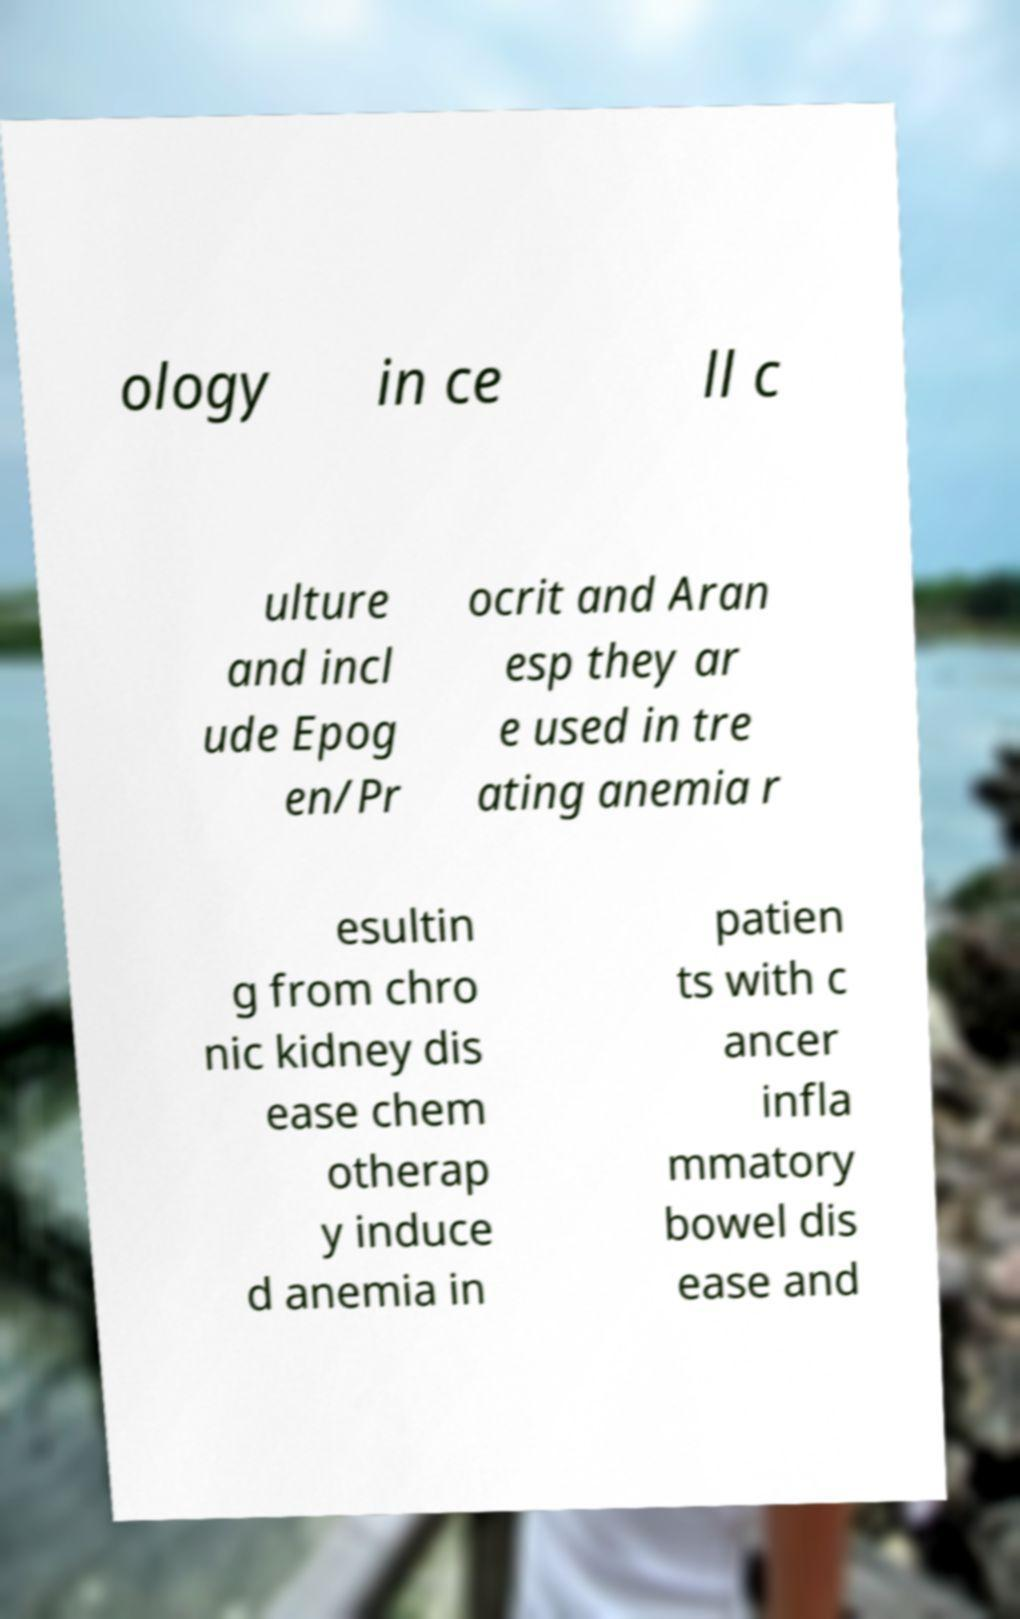What messages or text are displayed in this image? I need them in a readable, typed format. ology in ce ll c ulture and incl ude Epog en/Pr ocrit and Aran esp they ar e used in tre ating anemia r esultin g from chro nic kidney dis ease chem otherap y induce d anemia in patien ts with c ancer infla mmatory bowel dis ease and 